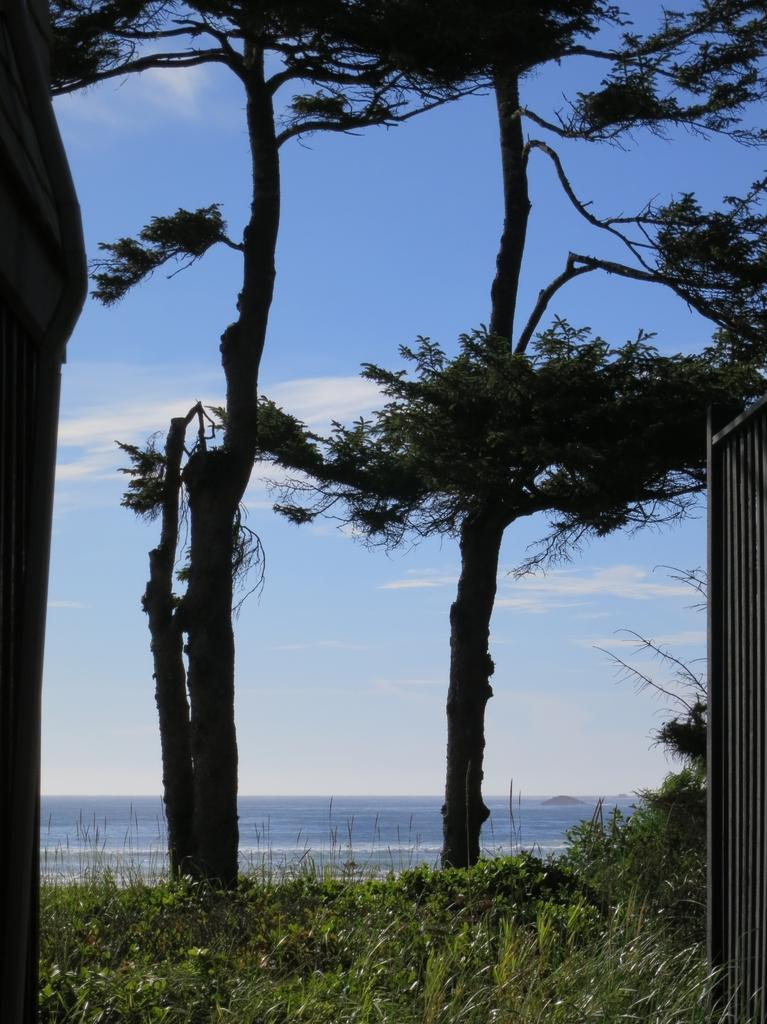What type of vegetation can be seen in the image? There is grass and trees in the image. What else can be seen in the image besides vegetation? There are other objects in the image. What is visible in the background of the image? Water and the sky are visible in the background of the image. What type of cable can be seen connecting the trees in the image? There is no cable connecting the trees in the image; only grass, trees, and other objects are present. 